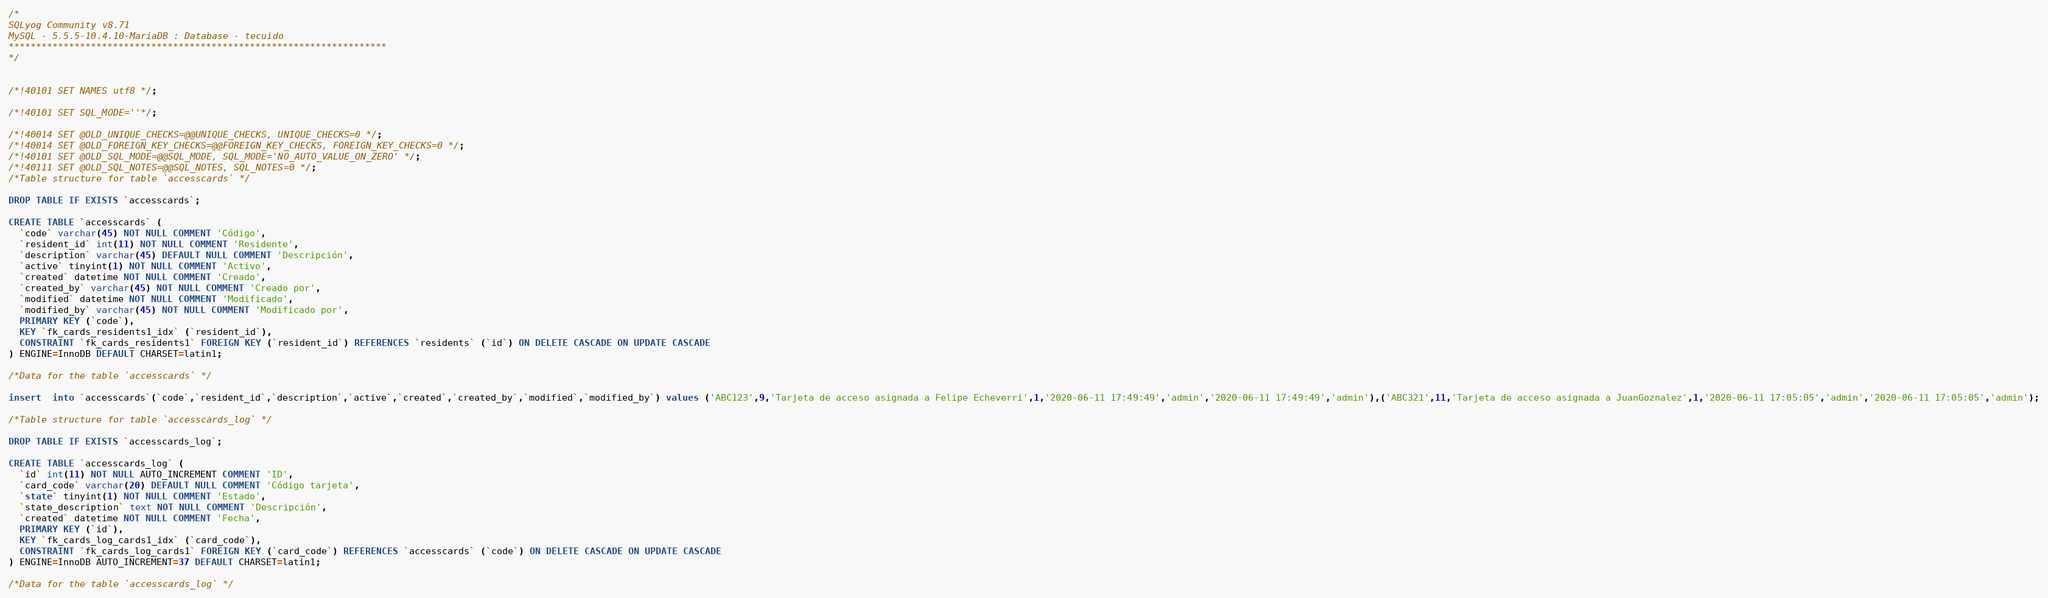<code> <loc_0><loc_0><loc_500><loc_500><_SQL_>/*
SQLyog Community v8.71 
MySQL - 5.5.5-10.4.10-MariaDB : Database - tecuido
*********************************************************************
*/

/*!40101 SET NAMES utf8 */;

/*!40101 SET SQL_MODE=''*/;

/*!40014 SET @OLD_UNIQUE_CHECKS=@@UNIQUE_CHECKS, UNIQUE_CHECKS=0 */;
/*!40014 SET @OLD_FOREIGN_KEY_CHECKS=@@FOREIGN_KEY_CHECKS, FOREIGN_KEY_CHECKS=0 */;
/*!40101 SET @OLD_SQL_MODE=@@SQL_MODE, SQL_MODE='NO_AUTO_VALUE_ON_ZERO' */;
/*!40111 SET @OLD_SQL_NOTES=@@SQL_NOTES, SQL_NOTES=0 */;
/*Table structure for table `accesscards` */

DROP TABLE IF EXISTS `accesscards`;

CREATE TABLE `accesscards` (
  `code` varchar(45) NOT NULL COMMENT 'Código',
  `resident_id` int(11) NOT NULL COMMENT 'Residente',
  `description` varchar(45) DEFAULT NULL COMMENT 'Descripción',
  `active` tinyint(1) NOT NULL COMMENT 'Activo',
  `created` datetime NOT NULL COMMENT 'Creado',
  `created_by` varchar(45) NOT NULL COMMENT 'Creado por',
  `modified` datetime NOT NULL COMMENT 'Modificado',
  `modified_by` varchar(45) NOT NULL COMMENT 'Modificado por',
  PRIMARY KEY (`code`),
  KEY `fk_cards_residents1_idx` (`resident_id`),
  CONSTRAINT `fk_cards_residents1` FOREIGN KEY (`resident_id`) REFERENCES `residents` (`id`) ON DELETE CASCADE ON UPDATE CASCADE
) ENGINE=InnoDB DEFAULT CHARSET=latin1;

/*Data for the table `accesscards` */

insert  into `accesscards`(`code`,`resident_id`,`description`,`active`,`created`,`created_by`,`modified`,`modified_by`) values ('ABC123',9,'Tarjeta de acceso asignada a Felipe Echeverri',1,'2020-06-11 17:49:49','admin','2020-06-11 17:49:49','admin'),('ABC321',11,'Tarjeta de acceso asignada a JuanGoznalez',1,'2020-06-11 17:05:05','admin','2020-06-11 17:05:05','admin');

/*Table structure for table `accesscards_log` */

DROP TABLE IF EXISTS `accesscards_log`;

CREATE TABLE `accesscards_log` (
  `id` int(11) NOT NULL AUTO_INCREMENT COMMENT 'ID',
  `card_code` varchar(20) DEFAULT NULL COMMENT 'Código tarjeta',
  `state` tinyint(1) NOT NULL COMMENT 'Estado',
  `state_description` text NOT NULL COMMENT 'Descripción',
  `created` datetime NOT NULL COMMENT 'Fecha',
  PRIMARY KEY (`id`),
  KEY `fk_cards_log_cards1_idx` (`card_code`),
  CONSTRAINT `fk_cards_log_cards1` FOREIGN KEY (`card_code`) REFERENCES `accesscards` (`code`) ON DELETE CASCADE ON UPDATE CASCADE
) ENGINE=InnoDB AUTO_INCREMENT=37 DEFAULT CHARSET=latin1;

/*Data for the table `accesscards_log` */
</code> 